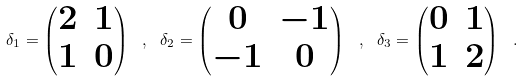Convert formula to latex. <formula><loc_0><loc_0><loc_500><loc_500>\delta _ { 1 } = \begin{pmatrix} 2 & 1 \\ 1 & 0 \end{pmatrix} \ , \ \delta _ { 2 } = \begin{pmatrix} 0 & - 1 \\ - 1 & 0 \end{pmatrix} \ , \ \delta _ { 3 } = \begin{pmatrix} 0 & 1 \\ 1 & 2 \end{pmatrix} \ . \</formula> 